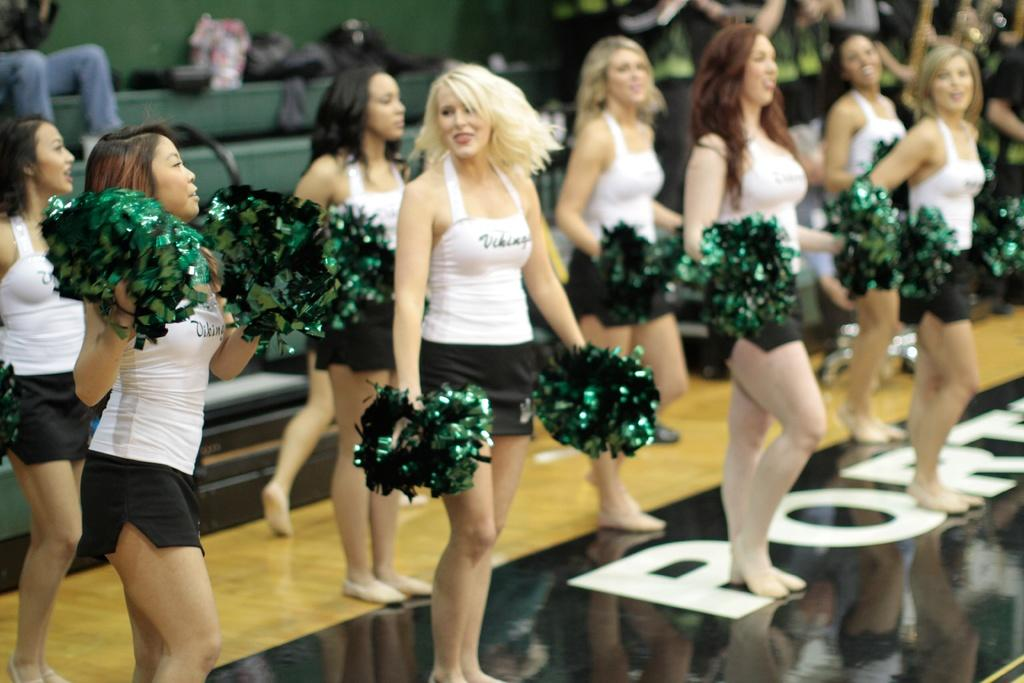What is happening in the middle of the image? There are women standing in the middle of the image. What are the women holding in their hands? The women are holding something in their hands. Can you describe the people behind the women? There are people sitting and standing behind the women. What objects can be seen in the image related to carrying items? There are bags visible in the image. What type of bomb can be seen in the image? There is no bomb present in the image. What kind of plastic material is visible in the image? There is no plastic material mentioned or visible in the image. 